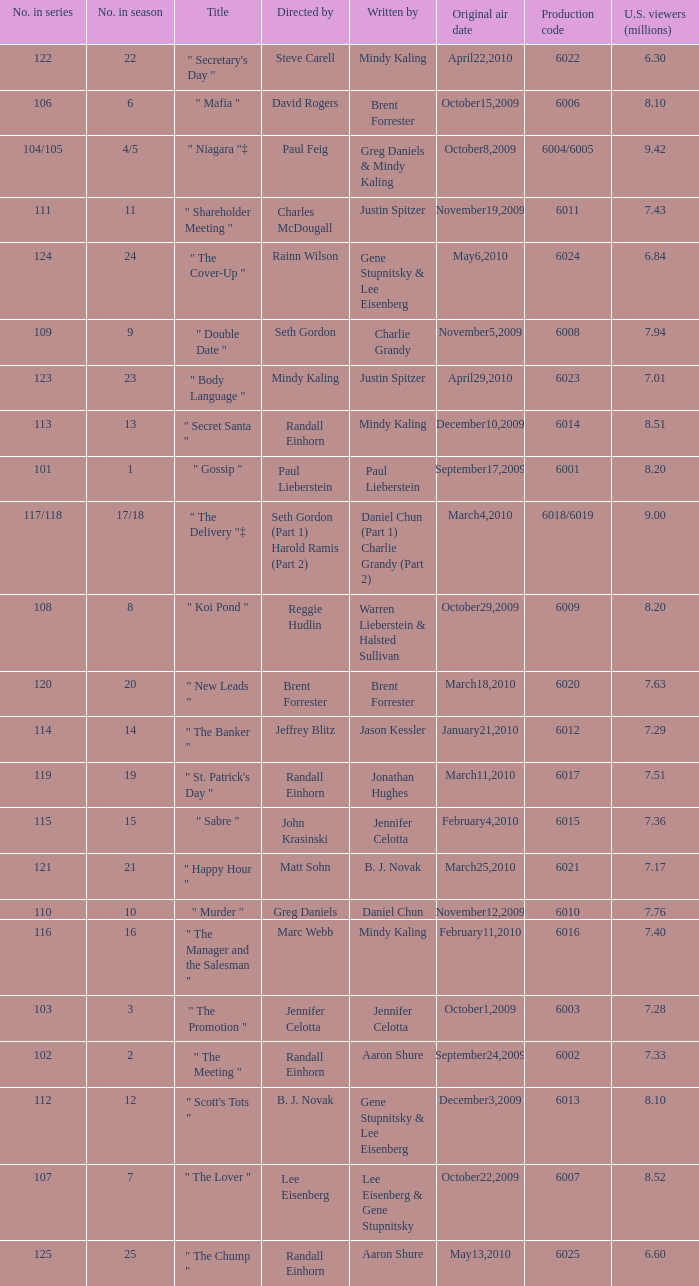Name the production code by paul lieberstein 6001.0. 